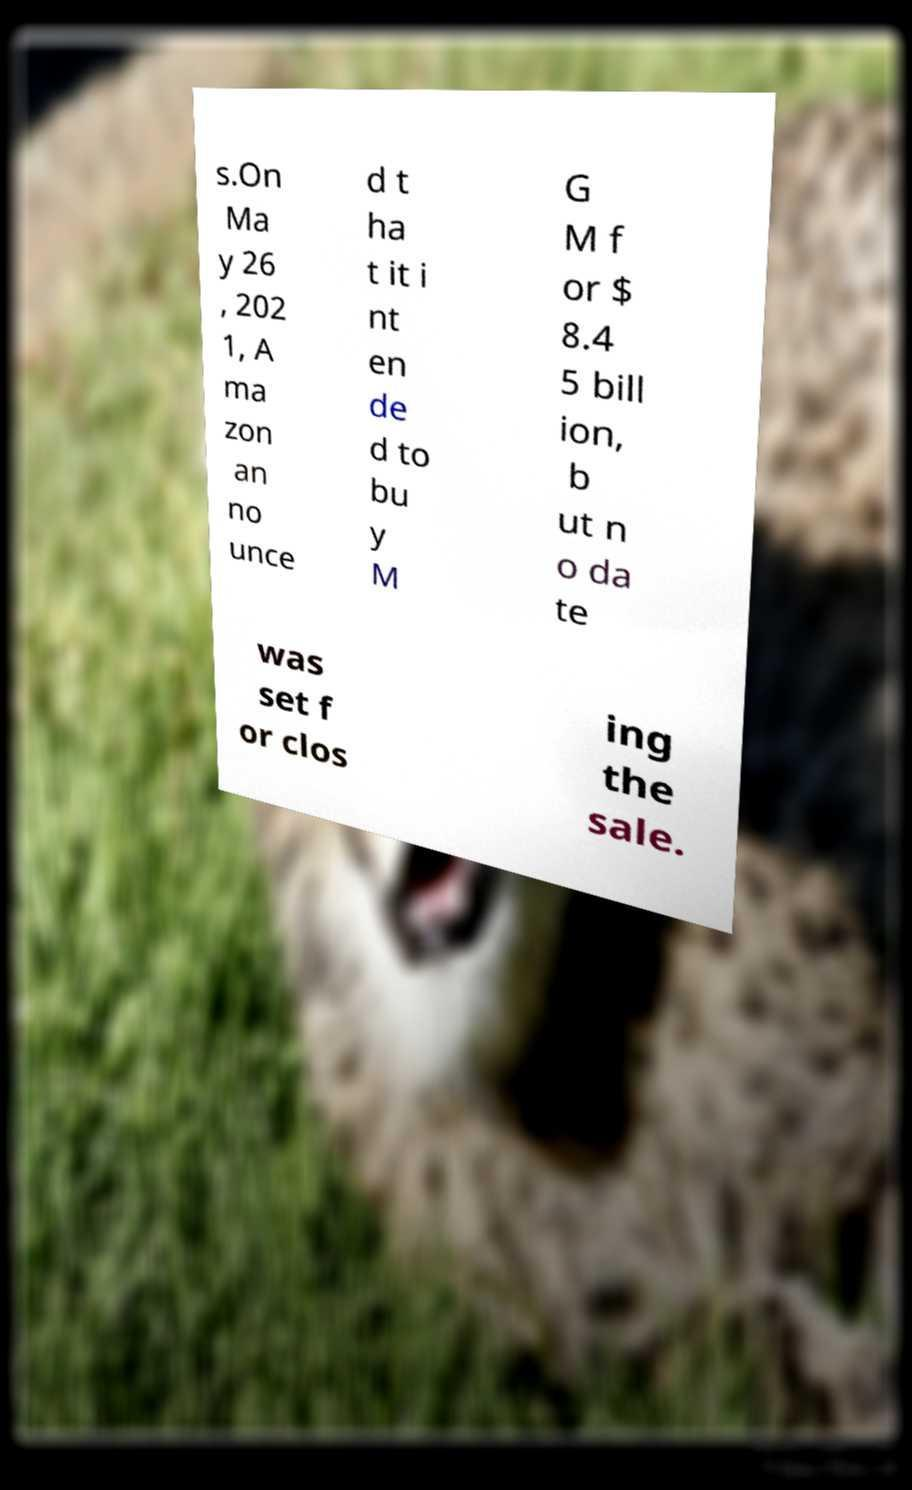Could you assist in decoding the text presented in this image and type it out clearly? s.On Ma y 26 , 202 1, A ma zon an no unce d t ha t it i nt en de d to bu y M G M f or $ 8.4 5 bill ion, b ut n o da te was set f or clos ing the sale. 